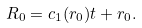Convert formula to latex. <formula><loc_0><loc_0><loc_500><loc_500>R _ { 0 } = c _ { 1 } ( r _ { 0 } ) t + r _ { 0 } .</formula> 